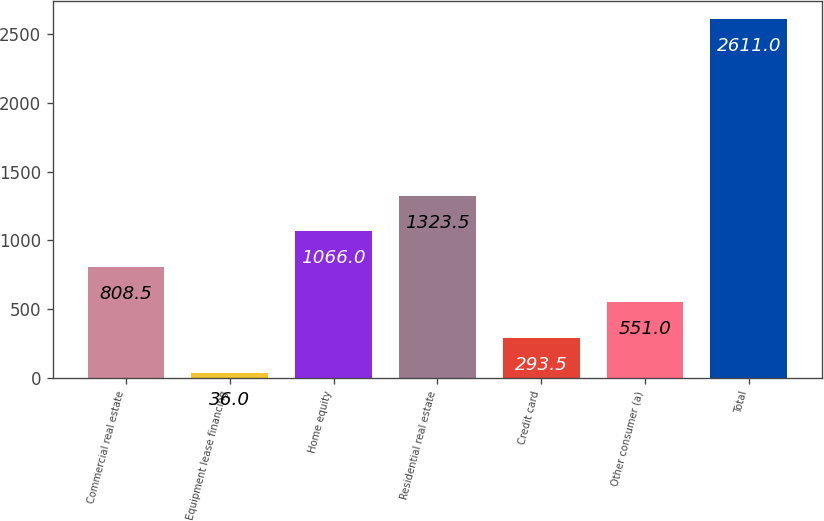Convert chart. <chart><loc_0><loc_0><loc_500><loc_500><bar_chart><fcel>Commercial real estate<fcel>Equipment lease financing<fcel>Home equity<fcel>Residential real estate<fcel>Credit card<fcel>Other consumer (a)<fcel>Total<nl><fcel>808.5<fcel>36<fcel>1066<fcel>1323.5<fcel>293.5<fcel>551<fcel>2611<nl></chart> 